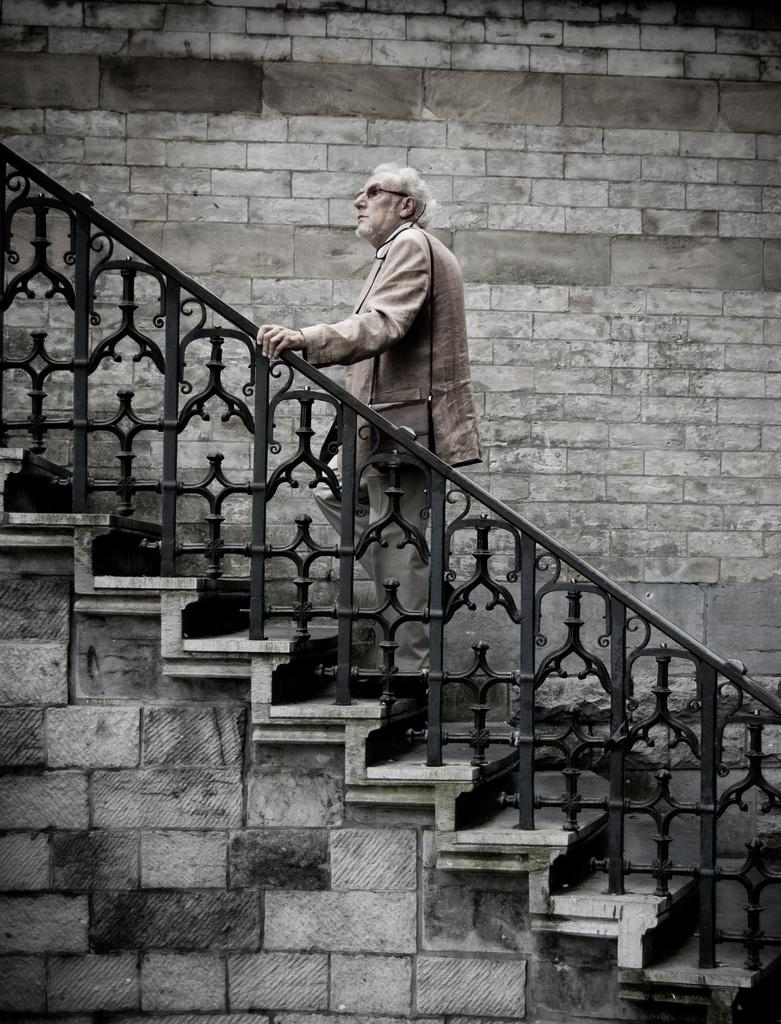Who is the main subject in the image? There is an old man in the image. What is the old man doing in the image? The old man is walking through steps in the image. What can be seen in the middle of the image? There is a stone wall in the middle of the image. What type of harmony can be heard in the image? There is no audible sound in the image, so it is not possible to determine if there is any harmony present. 